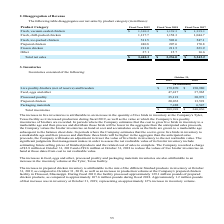From Sanderson Farms's financial document, What is the net sales from Fresh, vacuum-sealed chicken for fiscal years 2019 to 2017 respectively? The document contains multiple relevant values: $1,310.2, $1,139.3, $1,339.1 (in millions). From the document: "Fresh, vacuum-sealed chicken $ 1,310.2 $ 1,139.3 $ 1,339.1 resh, vacuum-sealed chicken $ 1,310.2 $ 1,139.3 $ 1,339.1 Fresh, vacuum-sealed chicken $ 1,..." Also, What is the net sales from Fresh, chill-packed chicken for fiscal years 2019 to 2017 respectively? The document contains multiple relevant values: 1,137.7, 1,158.3, 1,044.7 (in millions). From the document: "Fresh, chill-packed chicken 1,137.7 1,158.3 1,044.7 Fresh, chill-packed chicken 1,137.7 1,158.3 1,044.7 Fresh, chill-packed chicken 1,137.7 1,158.3 1,..." Also, What is the net sales from Fresh, ice-packed chicken for fiscal years 2019 to 2017 respectively? The document contains multiple relevant values: 511.5, 503.6, 547.1 (in millions). From the document: "Fresh, ice-packed chicken 511.5 503.6 547.1 Fresh, ice-packed chicken 511.5 503.6 547.1 Fresh, ice-packed chicken 511.5 503.6 547.1..." Also, can you calculate: What is the average net sales from Fresh, ice-packed chicken for fiscal years 2019 to 2017? To answer this question, I need to perform calculations using the financial data. The calculation is: (511.5+503.6+547.1)/3, which equals 520.73 (in millions). This is based on the information: "Fresh, ice-packed chicken 511.5 503.6 547.1 Fresh, ice-packed chicken 511.5 503.6 547.1 Fresh, ice-packed chicken 511.5 503.6 547.1..." The key data points involved are: 503.6, 511.5, 547.1. Also, can you calculate: What is the change in value of frozen chicken between fiscal year 2019 and 2018? Based on the calculation: 213.0-211.5, the result is 1.5 (in millions). This is based on the information: "Frozen chicken 213.0 211.5 223.9 Frozen chicken 213.0 211.5 223.9..." The key data points involved are: 211.5, 213.0. Also, can you calculate: What is the average net sales from Fresh, chill-packed chicken for fiscal years 2019 to 2017? To answer this question, I need to perform calculations using the financial data. The calculation is: (1,137.7+1,158.3+1,044.7)/3, which equals 1113.57 (in millions). This is based on the information: "Fresh, chill-packed chicken 1,137.7 1,158.3 1,044.7 Fresh, chill-packed chicken 1,137.7 1,158.3 1,044.7 Fresh, chill-packed chicken 1,137.7 1,158.3 1,044.7..." The key data points involved are: 1,044.7, 1,137.7, 1,158.3. 